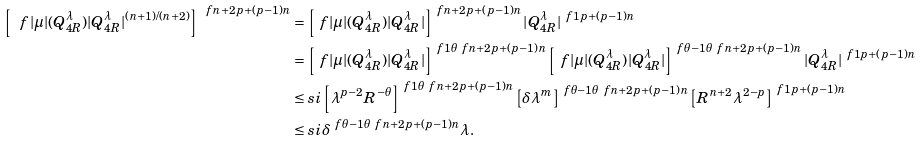Convert formula to latex. <formula><loc_0><loc_0><loc_500><loc_500>\left [ \ f { | \mu | ( Q ^ { \lambda } _ { 4 R } ) } { | Q ^ { \lambda } _ { 4 R } | ^ { ( n + 1 ) / ( n + 2 ) } } \right ] ^ { \ f { n + 2 } { p + ( p - 1 ) n } } & = \left [ \ f { | \mu | ( Q ^ { \lambda } _ { 4 R } ) } { | Q ^ { \lambda } _ { 4 R } | } \right ] ^ { \ f { n + 2 } { p + ( p - 1 ) n } } | Q ^ { \lambda } _ { 4 R } | ^ { \ f { 1 } { p + ( p - 1 ) n } } \\ & = \left [ \ f { | \mu | ( Q ^ { \lambda } _ { 4 R } ) } { | Q ^ { \lambda } _ { 4 R } | } \right ] ^ { \ f { 1 } { \theta } \ f { n + 2 } { p + ( p - 1 ) n } } \left [ \ f { | \mu | ( Q ^ { \lambda } _ { 4 R } ) } { | Q ^ { \lambda } _ { 4 R } | } \right ] ^ { \ f { \theta - 1 } { \theta } \ f { n + 2 } { p + ( p - 1 ) n } } | Q ^ { \lambda } _ { 4 R } | ^ { \ f { 1 } { p + ( p - 1 ) n } } \\ & \leq s i \left [ \lambda ^ { p - 2 } R ^ { - \theta } \right ] ^ { \ f { 1 } { \theta } \ f { n + 2 } { p + ( p - 1 ) n } } \left [ \delta \lambda ^ { m } \right ] ^ { \ f { \theta - 1 } { \theta } \ f { n + 2 } { p + ( p - 1 ) n } } \left [ R ^ { n + 2 } \lambda ^ { 2 - p } \right ] ^ { \ f { 1 } { p + ( p - 1 ) n } } \\ & \leq s i \delta ^ { \ f { \theta - 1 } { \theta } \ f { n + 2 } { p + ( p - 1 ) n } } \lambda .</formula> 